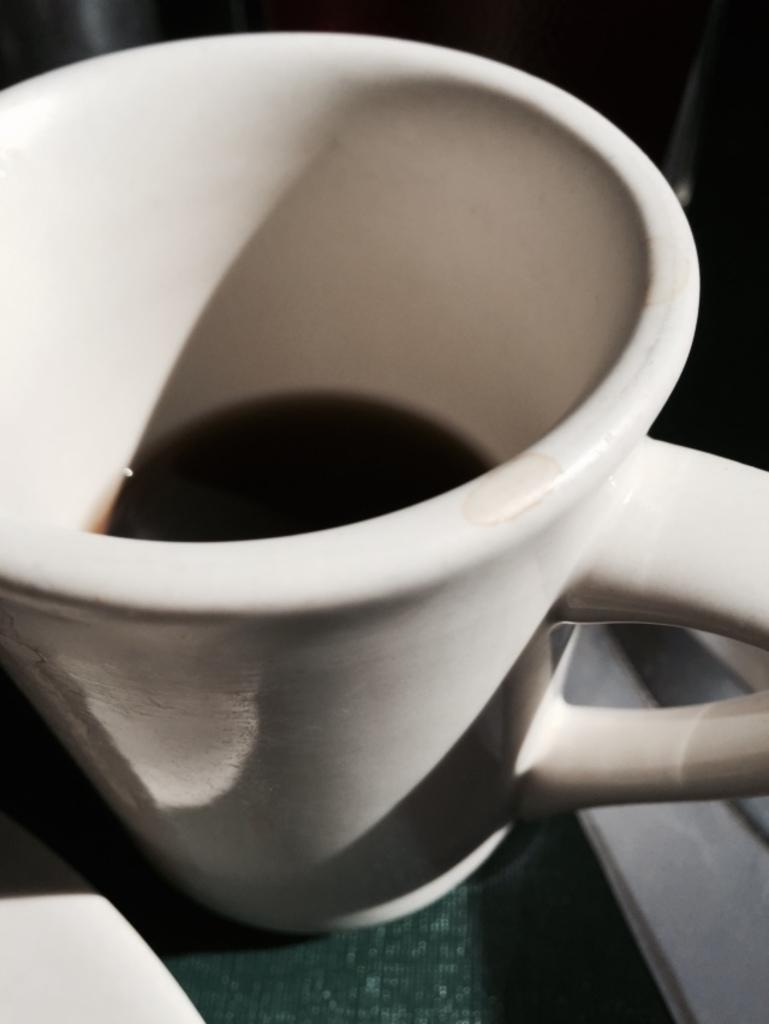What object is present in the image that is typically used for holding liquids? There is a white cup in the image. What is inside the cup? The cup contains liquid. What type of voice can be heard coming from the cup in the image? There is no voice coming from the cup in the image, as it is a white cup containing liquid. 